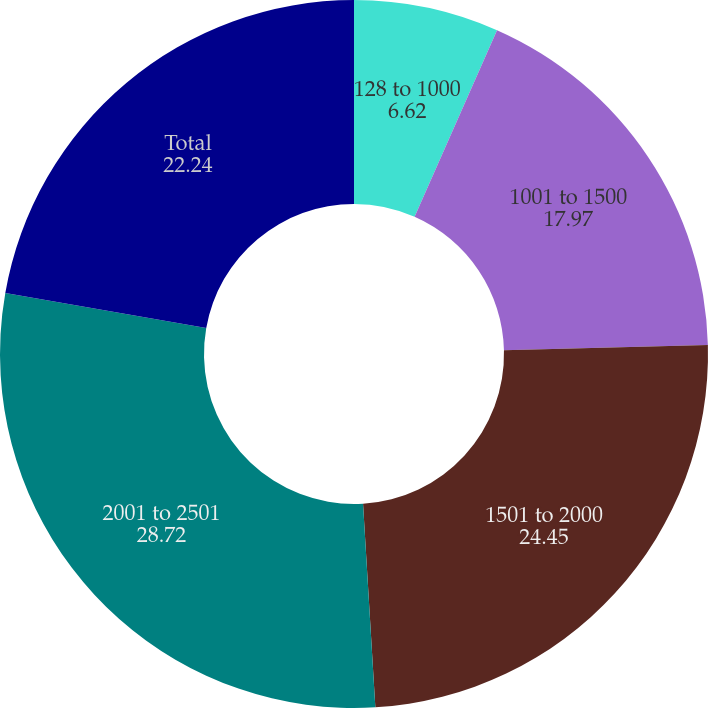Convert chart to OTSL. <chart><loc_0><loc_0><loc_500><loc_500><pie_chart><fcel>128 to 1000<fcel>1001 to 1500<fcel>1501 to 2000<fcel>2001 to 2501<fcel>Total<nl><fcel>6.62%<fcel>17.97%<fcel>24.45%<fcel>28.72%<fcel>22.24%<nl></chart> 